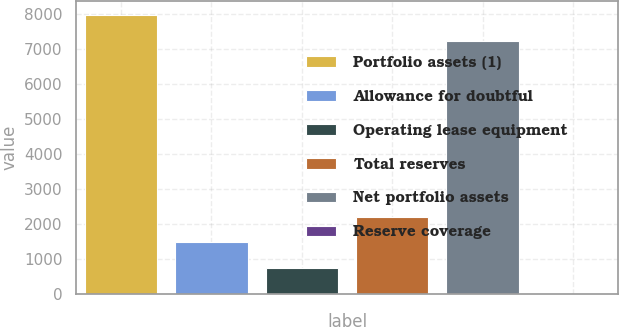Convert chart. <chart><loc_0><loc_0><loc_500><loc_500><bar_chart><fcel>Portfolio assets (1)<fcel>Allowance for doubtful<fcel>Operating lease equipment<fcel>Total reserves<fcel>Net portfolio assets<fcel>Reserve coverage<nl><fcel>7957.33<fcel>1470.36<fcel>736.03<fcel>2204.69<fcel>7223<fcel>1.7<nl></chart> 